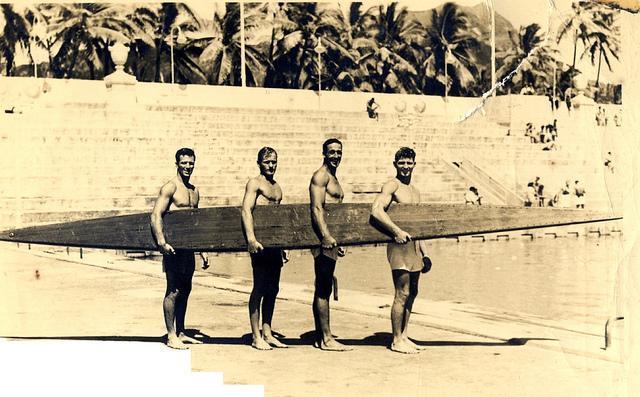How many people are wearing shirts?
Give a very brief answer. 0. How many people are in the photo?
Give a very brief answer. 4. How many people are there?
Give a very brief answer. 4. How many birds are there?
Give a very brief answer. 0. 